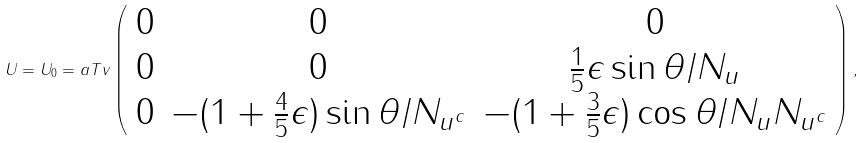Convert formula to latex. <formula><loc_0><loc_0><loc_500><loc_500>U = U _ { 0 } = a T v \left ( \begin{array} { c c c } 0 & 0 & 0 \\ 0 & 0 & \frac { 1 } { 5 } \epsilon \sin \theta / N _ { u } \\ 0 & - ( 1 + \frac { 4 } { 5 } \epsilon ) \sin \theta / N _ { u ^ { c } } & - ( 1 + \frac { 3 } { 5 } \epsilon ) \cos \theta / N _ { u } N _ { u ^ { c } } \end{array} \right ) ,</formula> 